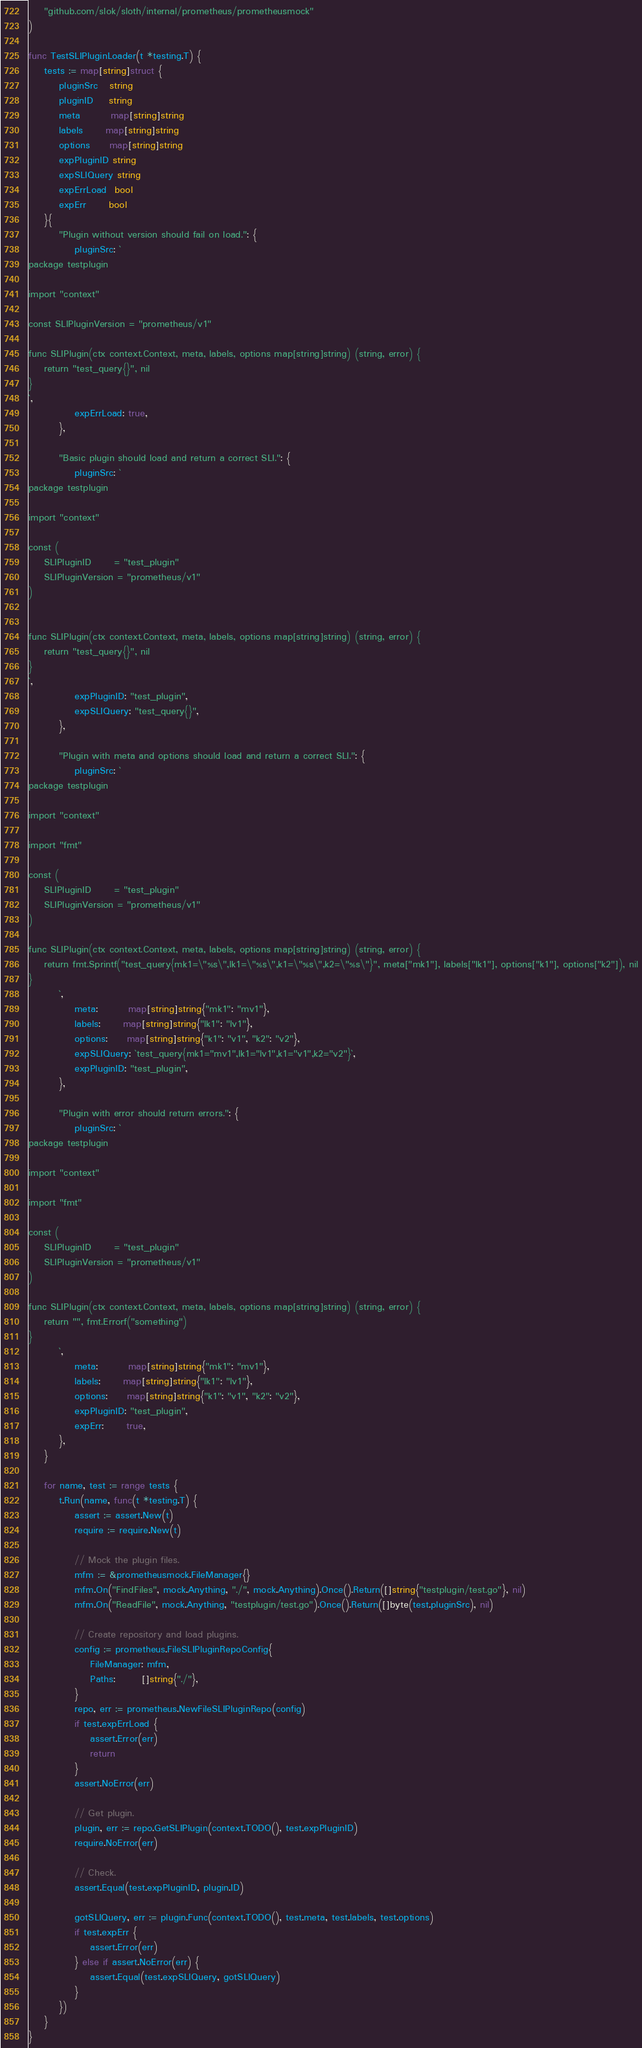<code> <loc_0><loc_0><loc_500><loc_500><_Go_>	"github.com/slok/sloth/internal/prometheus/prometheusmock"
)

func TestSLIPluginLoader(t *testing.T) {
	tests := map[string]struct {
		pluginSrc   string
		pluginID    string
		meta        map[string]string
		labels      map[string]string
		options     map[string]string
		expPluginID string
		expSLIQuery string
		expErrLoad  bool
		expErr      bool
	}{
		"Plugin without version should fail on load.": {
			pluginSrc: `
package testplugin

import "context"

const SLIPluginVersion = "prometheus/v1"

func SLIPlugin(ctx context.Context, meta, labels, options map[string]string) (string, error) {
	return "test_query{}", nil
}
`,
			expErrLoad: true,
		},

		"Basic plugin should load and return a correct SLI.": {
			pluginSrc: `
package testplugin

import "context"

const (
	SLIPluginID      = "test_plugin"
	SLIPluginVersion = "prometheus/v1"
)


func SLIPlugin(ctx context.Context, meta, labels, options map[string]string) (string, error) {
	return "test_query{}", nil
}
`,
			expPluginID: "test_plugin",
			expSLIQuery: "test_query{}",
		},

		"Plugin with meta and options should load and return a correct SLI.": {
			pluginSrc: `
package testplugin

import "context"

import "fmt"

const (
	SLIPluginID      = "test_plugin"
	SLIPluginVersion = "prometheus/v1"
)

func SLIPlugin(ctx context.Context, meta, labels, options map[string]string) (string, error) {
	return fmt.Sprintf("test_query{mk1=\"%s\",lk1=\"%s\",k1=\"%s\",k2=\"%s\"}", meta["mk1"], labels["lk1"], options["k1"], options["k2"]), nil
}
		`,
			meta:        map[string]string{"mk1": "mv1"},
			labels:      map[string]string{"lk1": "lv1"},
			options:     map[string]string{"k1": "v1", "k2": "v2"},
			expSLIQuery: `test_query{mk1="mv1",lk1="lv1",k1="v1",k2="v2"}`,
			expPluginID: "test_plugin",
		},

		"Plugin with error should return errors.": {
			pluginSrc: `
package testplugin

import "context"

import "fmt"

const (
	SLIPluginID      = "test_plugin"
	SLIPluginVersion = "prometheus/v1"
)

func SLIPlugin(ctx context.Context, meta, labels, options map[string]string) (string, error) {
	return "", fmt.Errorf("something")
}
		`,
			meta:        map[string]string{"mk1": "mv1"},
			labels:      map[string]string{"lk1": "lv1"},
			options:     map[string]string{"k1": "v1", "k2": "v2"},
			expPluginID: "test_plugin",
			expErr:      true,
		},
	}

	for name, test := range tests {
		t.Run(name, func(t *testing.T) {
			assert := assert.New(t)
			require := require.New(t)

			// Mock the plugin files.
			mfm := &prometheusmock.FileManager{}
			mfm.On("FindFiles", mock.Anything, "./", mock.Anything).Once().Return([]string{"testplugin/test.go"}, nil)
			mfm.On("ReadFile", mock.Anything, "testplugin/test.go").Once().Return([]byte(test.pluginSrc), nil)

			// Create repository and load plugins.
			config := prometheus.FileSLIPluginRepoConfig{
				FileManager: mfm,
				Paths:       []string{"./"},
			}
			repo, err := prometheus.NewFileSLIPluginRepo(config)
			if test.expErrLoad {
				assert.Error(err)
				return
			}
			assert.NoError(err)

			// Get plugin.
			plugin, err := repo.GetSLIPlugin(context.TODO(), test.expPluginID)
			require.NoError(err)

			// Check.
			assert.Equal(test.expPluginID, plugin.ID)

			gotSLIQuery, err := plugin.Func(context.TODO(), test.meta, test.labels, test.options)
			if test.expErr {
				assert.Error(err)
			} else if assert.NoError(err) {
				assert.Equal(test.expSLIQuery, gotSLIQuery)
			}
		})
	}
}
</code> 